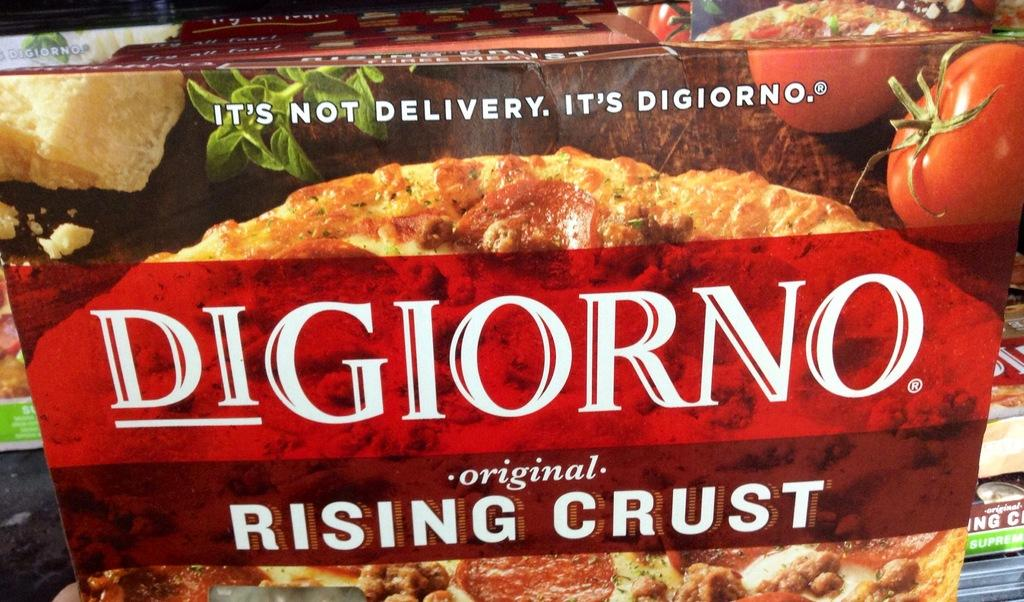What object is present in the image? There is a box in the image. What can be seen on the surface of the box? The box has images and labels on it. What type of breakfast is being prepared on the stage in the image? There is no stage or breakfast present in the image; it only features a box with images and labels on it. 